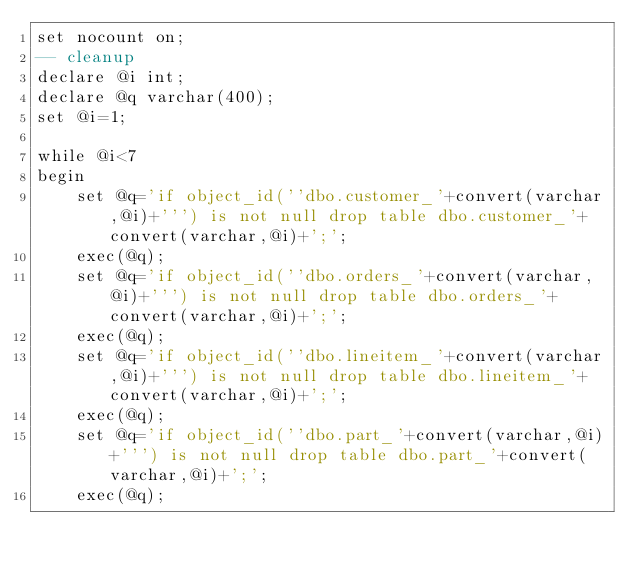Convert code to text. <code><loc_0><loc_0><loc_500><loc_500><_SQL_>set nocount on;
-- cleanup
declare @i int;
declare @q varchar(400);
set @i=1;

while @i<7
begin
	set @q='if object_id(''dbo.customer_'+convert(varchar,@i)+''') is not null drop table dbo.customer_'+convert(varchar,@i)+';';
	exec(@q);
	set @q='if object_id(''dbo.orders_'+convert(varchar,@i)+''') is not null drop table dbo.orders_'+convert(varchar,@i)+';';
	exec(@q);
	set @q='if object_id(''dbo.lineitem_'+convert(varchar,@i)+''') is not null drop table dbo.lineitem_'+convert(varchar,@i)+';';
	exec(@q);
	set @q='if object_id(''dbo.part_'+convert(varchar,@i)+''') is not null drop table dbo.part_'+convert(varchar,@i)+';';
	exec(@q);</code> 